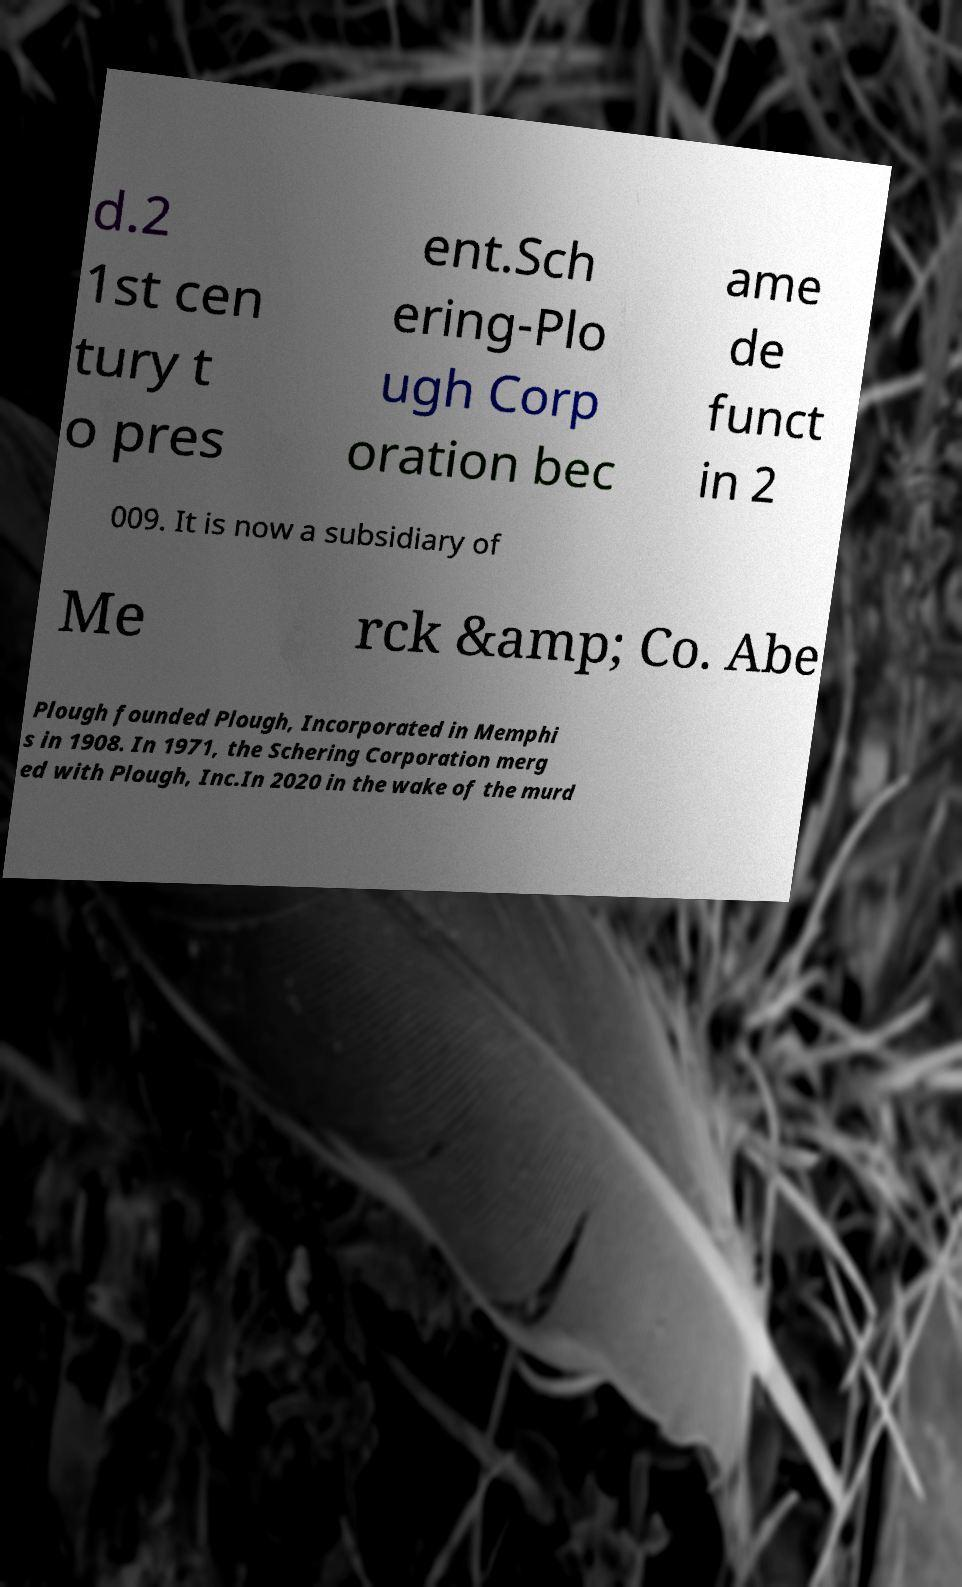Please identify and transcribe the text found in this image. d.2 1st cen tury t o pres ent.Sch ering-Plo ugh Corp oration bec ame de funct in 2 009. It is now a subsidiary of Me rck &amp; Co. Abe Plough founded Plough, Incorporated in Memphi s in 1908. In 1971, the Schering Corporation merg ed with Plough, Inc.In 2020 in the wake of the murd 